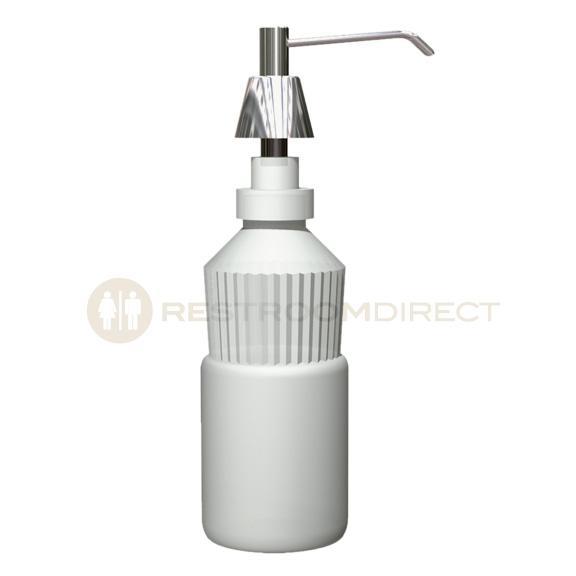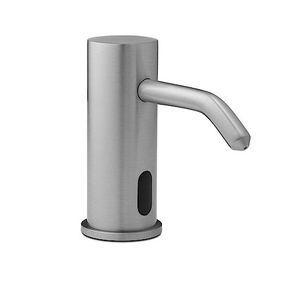The first image is the image on the left, the second image is the image on the right. Given the left and right images, does the statement "In one of the images, there is a manual soap dispenser with a nozzle facing left." hold true? Answer yes or no. No. 